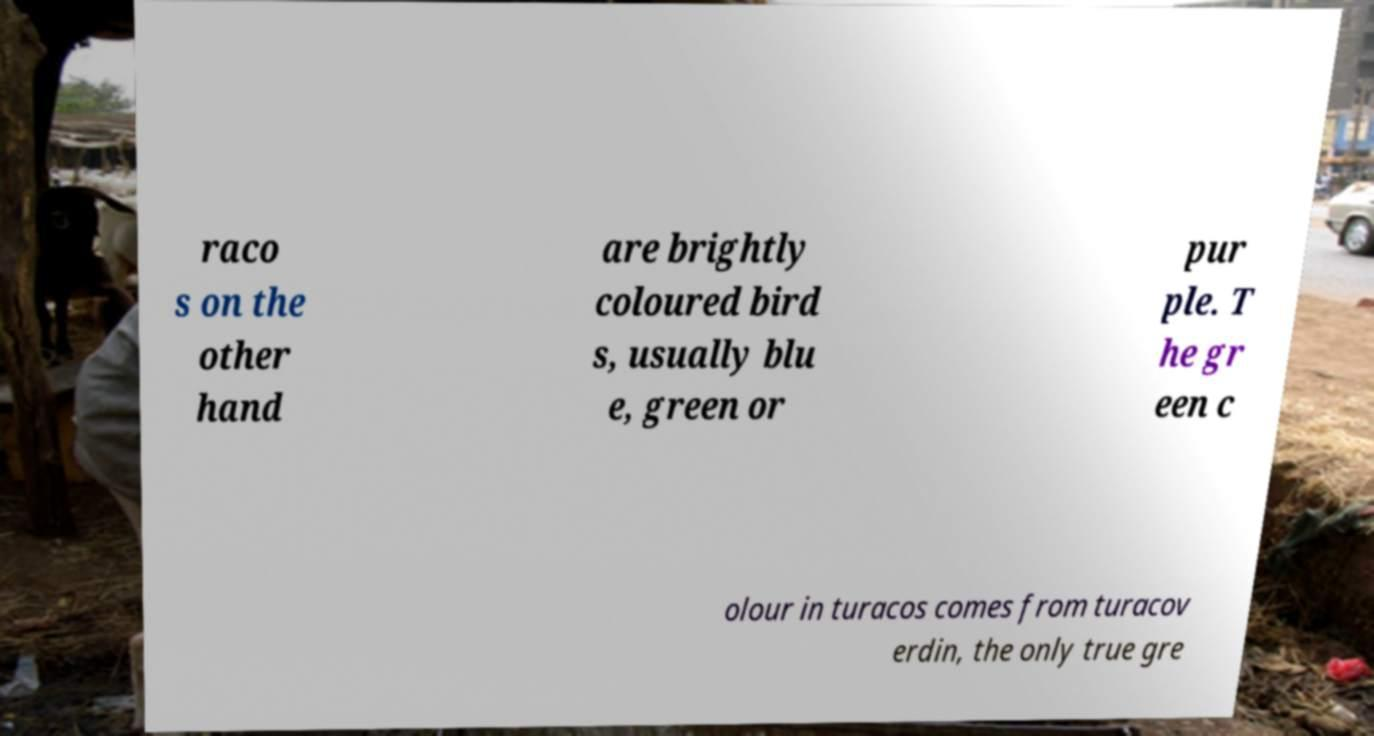Could you extract and type out the text from this image? raco s on the other hand are brightly coloured bird s, usually blu e, green or pur ple. T he gr een c olour in turacos comes from turacov erdin, the only true gre 